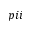<formula> <loc_0><loc_0><loc_500><loc_500>p i i</formula> 